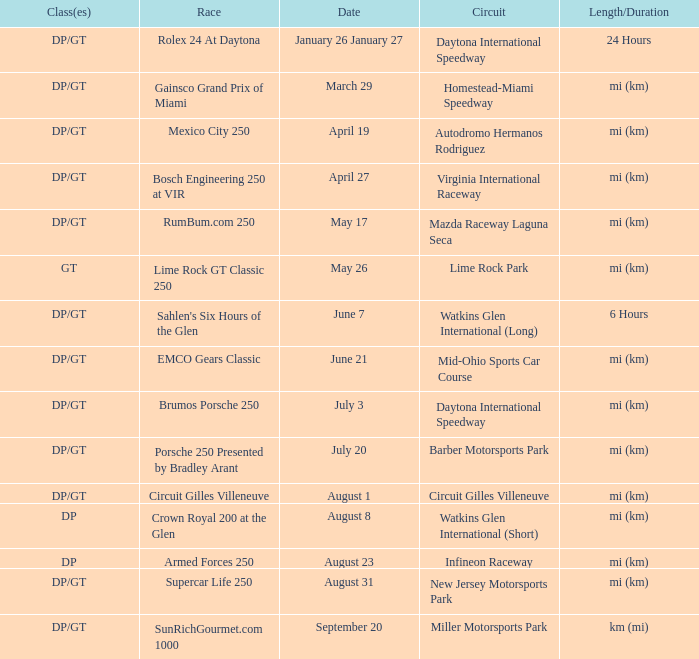What was the circuit had a race on September 20. Miller Motorsports Park. Give me the full table as a dictionary. {'header': ['Class(es)', 'Race', 'Date', 'Circuit', 'Length/Duration'], 'rows': [['DP/GT', 'Rolex 24 At Daytona', 'January 26 January 27', 'Daytona International Speedway', '24 Hours'], ['DP/GT', 'Gainsco Grand Prix of Miami', 'March 29', 'Homestead-Miami Speedway', 'mi (km)'], ['DP/GT', 'Mexico City 250', 'April 19', 'Autodromo Hermanos Rodriguez', 'mi (km)'], ['DP/GT', 'Bosch Engineering 250 at VIR', 'April 27', 'Virginia International Raceway', 'mi (km)'], ['DP/GT', 'RumBum.com 250', 'May 17', 'Mazda Raceway Laguna Seca', 'mi (km)'], ['GT', 'Lime Rock GT Classic 250', 'May 26', 'Lime Rock Park', 'mi (km)'], ['DP/GT', "Sahlen's Six Hours of the Glen", 'June 7', 'Watkins Glen International (Long)', '6 Hours'], ['DP/GT', 'EMCO Gears Classic', 'June 21', 'Mid-Ohio Sports Car Course', 'mi (km)'], ['DP/GT', 'Brumos Porsche 250', 'July 3', 'Daytona International Speedway', 'mi (km)'], ['DP/GT', 'Porsche 250 Presented by Bradley Arant', 'July 20', 'Barber Motorsports Park', 'mi (km)'], ['DP/GT', 'Circuit Gilles Villeneuve', 'August 1', 'Circuit Gilles Villeneuve', 'mi (km)'], ['DP', 'Crown Royal 200 at the Glen', 'August 8', 'Watkins Glen International (Short)', 'mi (km)'], ['DP', 'Armed Forces 250', 'August 23', 'Infineon Raceway', 'mi (km)'], ['DP/GT', 'Supercar Life 250', 'August 31', 'New Jersey Motorsports Park', 'mi (km)'], ['DP/GT', 'SunRichGourmet.com 1000', 'September 20', 'Miller Motorsports Park', 'km (mi)']]} 